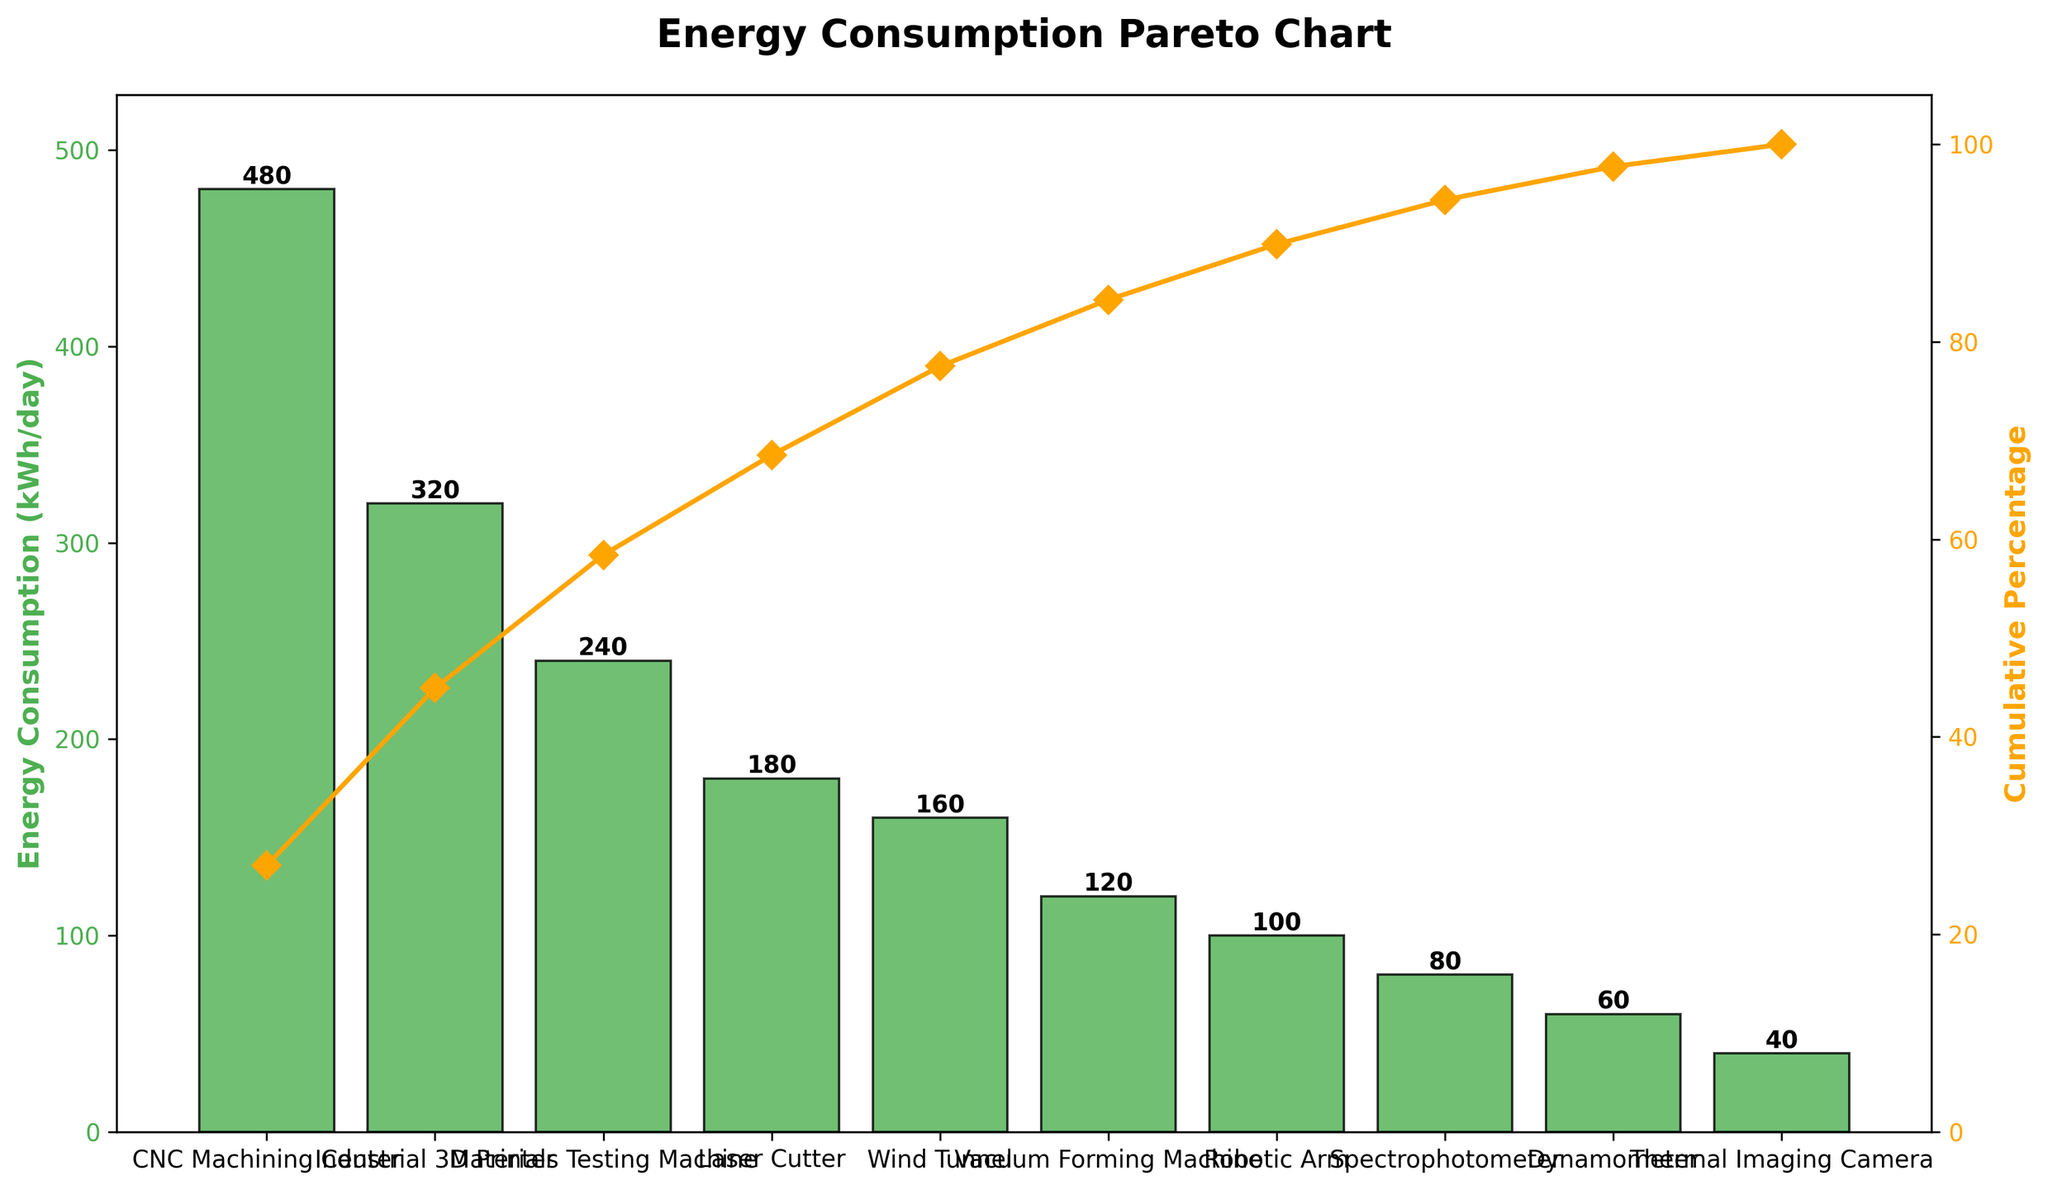What is the title of the chart? The title is written at the top of the chart and it summarizes the main focus of the visualization. In this example, the title is "Energy Consumption Pareto Chart" as the intent is to display the energy consumption of various R&D equipment in order.
Answer: Energy Consumption Pareto Chart Which equipment has the highest energy consumption? The equipment with the highest bar in the chart represents the highest energy consumption. In this case, the CNC Machining Center has the tallest bar.
Answer: CNC Machining Center How many pieces of equipment are listed in the chart? Count the number of distinct bars which represent different pieces of equipment. Here, there are ten bars, each representing a different piece of equipment.
Answer: 10 What is the cumulative percentage of energy consumption after the third highest consuming equipment? To find the cumulative percentage, look at the value on the secondary y-axis (cumulative percentage) corresponding to the third highest consuming equipment. Here, the third highest is the Materials Testing Machine. The cumulative percentage at this point is around 65%.
Answer: ~65% What is the difference in energy consumption between the CNC Machining Center and the Dynamometer? Subtract the energy consumption value of the Dynamometer from the CNC Machining Center. The CNC Machining Center consumes 480 kWh/day and the Dynamometer consumes 60 kWh/day. The difference is 480 - 60 = 420 kWh/day.
Answer: 420 kWh/day Which equipment is positioned at the median point of the Pareto chart? To find the median point, locate the middle equipment in the ordered list. Here, with 10 pieces of equipment, the median would be between the 5th (Wind Tunnel) and 6th (Vacuum Forming Machine) equipment.
Answer: Between Wind Tunnel and Vacuum Forming Machine What color are the bars representing energy consumption? The bars representing energy consumption are colored in a distinctive shade, in this case, a green hue (#4CAF50). This is evident from the visual contrast in the chart.
Answer: Green At which point does the cumulative percentage reach approximately 90%? Observe the secondary y-axis (cumulative percentage) and locate the point where the line reaches 90%. This occurs around the Robotic Arm, which is the 7th piece of equipment.
Answer: Robotic Arm Which piece of equipment contributes the least to the energy consumption? The shortest bar in the chart indicates the equipment with the least energy consumption. In this scenario, the Thermal Imaging Camera has the lowest bar.
Answer: Thermal Imaging Camera How many equipment pieces cumulatively contribute to at least 50% of the total energy consumption? To find this, summing the cumulative percentages visually until reaching 50%. The first three pieces of equipment (CNC Machining Center, Industrial 3D Printer, and Materials Testing Machine) together surpass 50%.
Answer: 3 